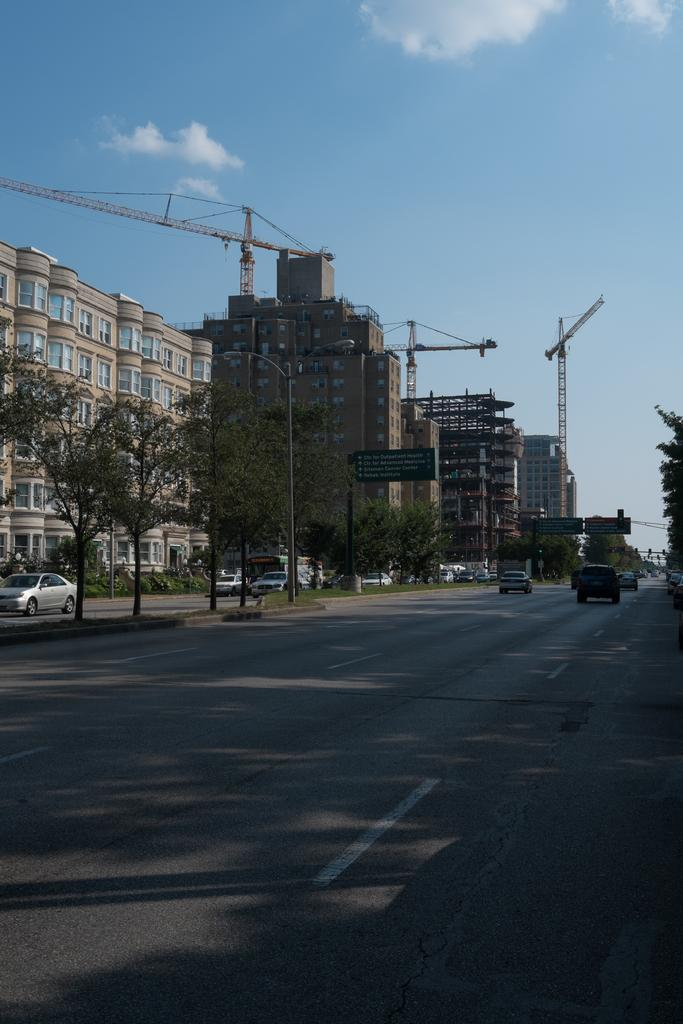What type of location is depicted in the image? The image is of a city. What can be seen in the foreground of the image? There is a road in the foreground of the image. What is located in the center of the image? There are buildings, cranes, trees, and cars present in the center of the image. What is the condition of the sky in the image? The sky is clear in the image. What is the weather like in the image? It is sunny in the image. How many girls are playing with the cranes in the image? There are no girls present in the image, and the cranes are not being played with; they are construction equipment. 